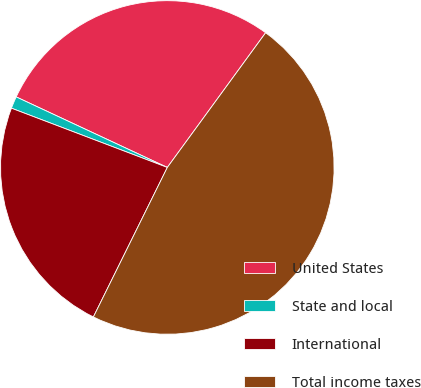Convert chart to OTSL. <chart><loc_0><loc_0><loc_500><loc_500><pie_chart><fcel>United States<fcel>State and local<fcel>International<fcel>Total income taxes<nl><fcel>28.08%<fcel>1.17%<fcel>23.47%<fcel>47.27%<nl></chart> 